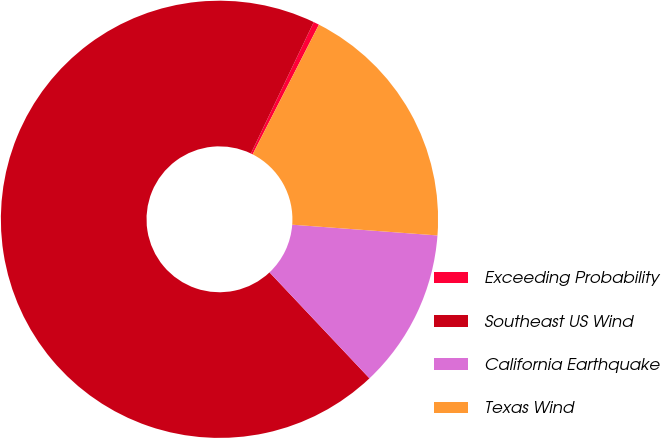Convert chart to OTSL. <chart><loc_0><loc_0><loc_500><loc_500><pie_chart><fcel>Exceeding Probability<fcel>Southeast US Wind<fcel>California Earthquake<fcel>Texas Wind<nl><fcel>0.42%<fcel>69.14%<fcel>11.79%<fcel>18.66%<nl></chart> 